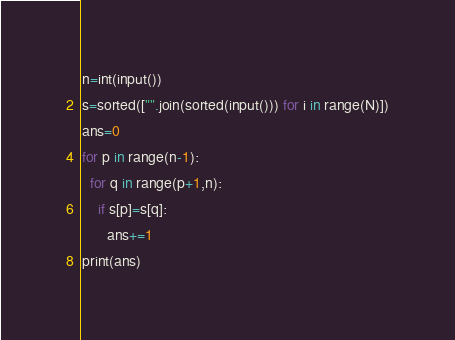<code> <loc_0><loc_0><loc_500><loc_500><_Python_>n=int(input())
s=sorted(["".join(sorted(input())) for i in range(N)])
ans=0
for p in range(n-1):
  for q in range(p+1,n):
    if s[p]=s[q]:
      ans+=1
print(ans)</code> 